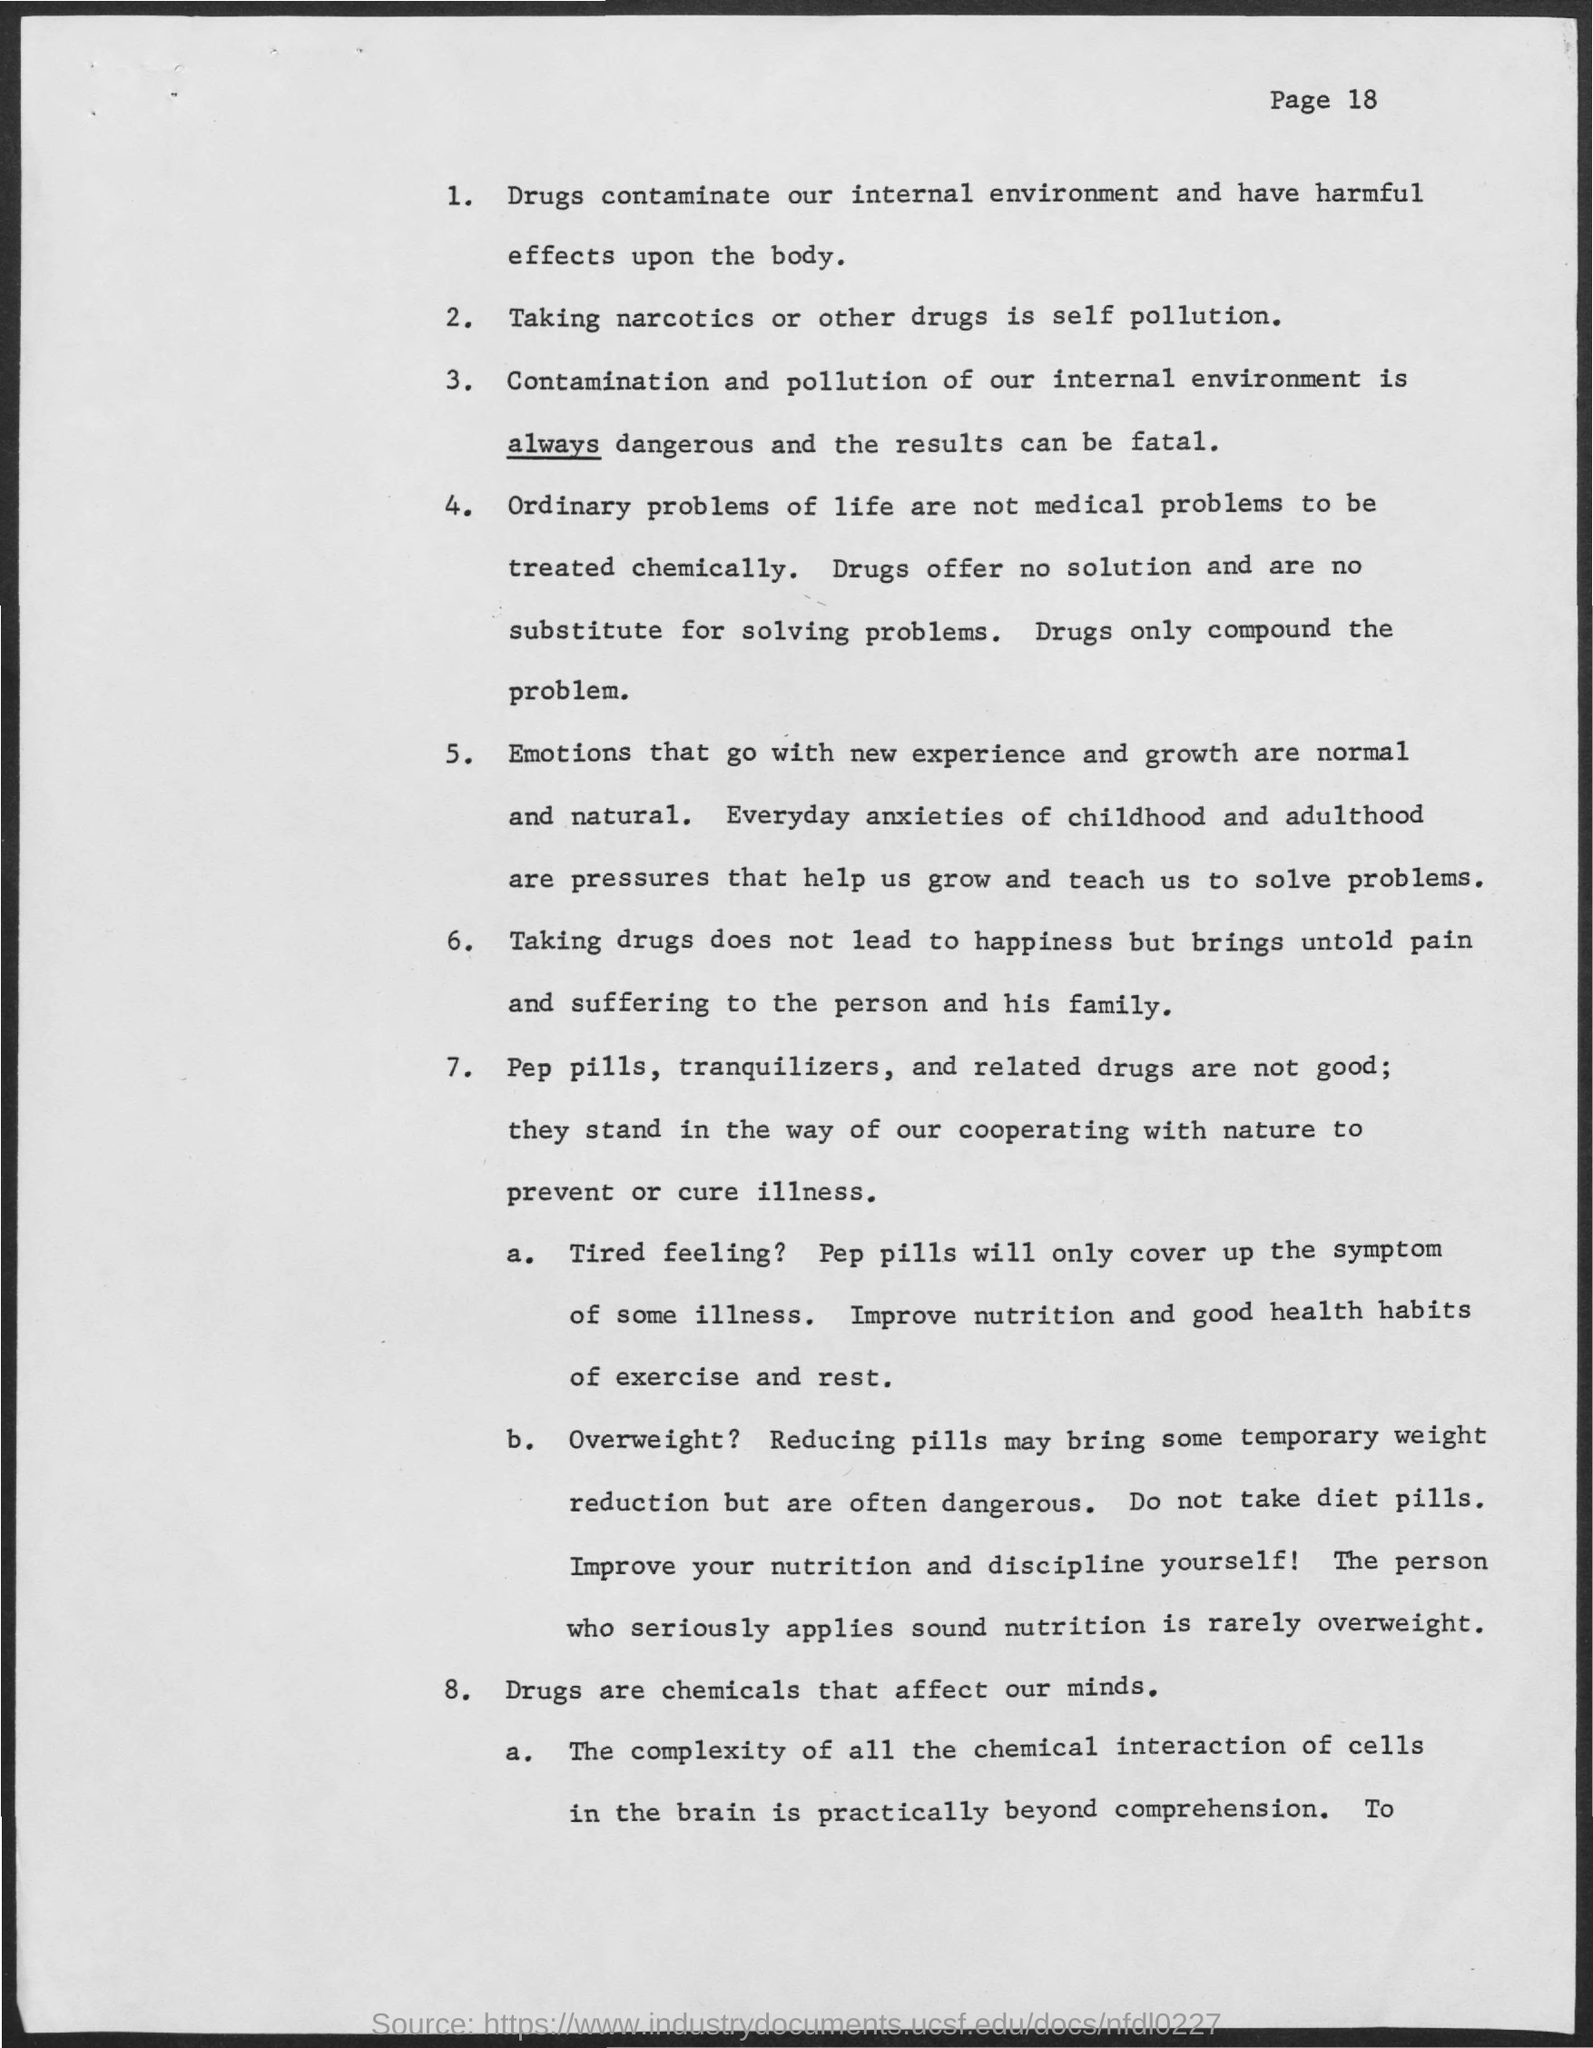What is the Page Number?
Provide a succinct answer. 18. Taking narcotics or other drugs is what?
Offer a terse response. Self pollution. 